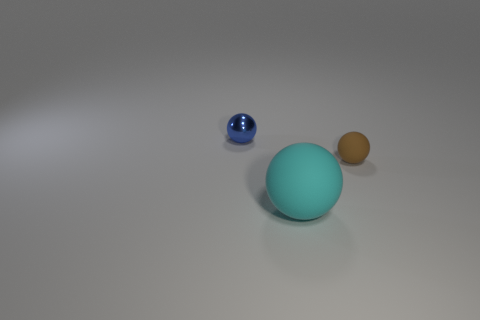Is the number of small blue metallic objects greater than the number of small yellow metallic blocks?
Give a very brief answer. Yes. Are there any big purple objects that have the same shape as the tiny blue object?
Provide a succinct answer. No. There is a matte object behind the cyan rubber ball; what shape is it?
Give a very brief answer. Sphere. There is a rubber thing in front of the matte object that is behind the big rubber object; what number of small brown matte balls are behind it?
Provide a short and direct response. 1. What number of other things are the same shape as the large cyan rubber thing?
Provide a succinct answer. 2. How many other objects are there of the same material as the blue object?
Ensure brevity in your answer.  0. What material is the ball that is behind the small sphere that is right of the thing behind the tiny brown object made of?
Make the answer very short. Metal. Is the material of the big ball the same as the tiny brown thing?
Keep it short and to the point. Yes. How many spheres are matte things or small metallic objects?
Keep it short and to the point. 3. There is a small sphere that is in front of the blue shiny ball; what color is it?
Give a very brief answer. Brown. 